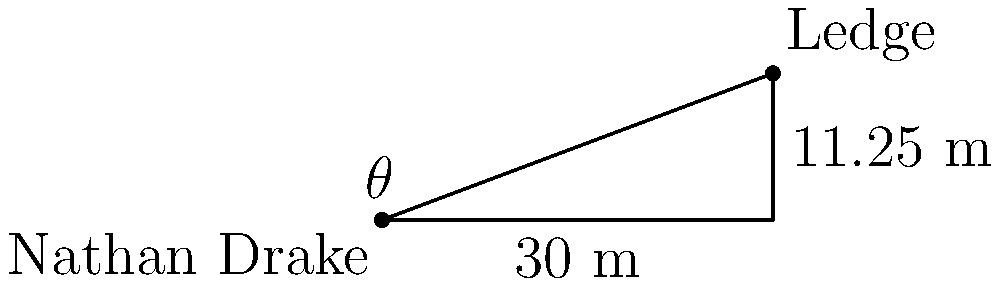Nathan Drake needs to use his grappling hook to reach a ledge. The ledge is 30 meters away horizontally and 11.25 meters above his current position. What angle of elevation (in degrees) should Nathan aim his grappling hook to reach the ledge? To solve this problem, we'll use trigonometry. Let's approach this step-by-step:

1) We can treat this scenario as a right triangle, where:
   - The horizontal distance is the base of the triangle (30 m)
   - The vertical height is the opposite side (11.25 m)
   - The angle we're looking for is the angle of elevation (let's call it $\theta$)

2) In a right triangle, we can use the tangent function to find the angle:

   $\tan(\theta) = \frac{\text{opposite}}{\text{adjacent}} = \frac{\text{height}}{\text{horizontal distance}}$

3) Plugging in our values:

   $\tan(\theta) = \frac{11.25}{30}$

4) To find $\theta$, we need to use the inverse tangent (arctan or $\tan^{-1}$):

   $\theta = \tan^{-1}(\frac{11.25}{30})$

5) Using a calculator or computer:

   $\theta \approx 20.556°$

6) Rounding to the nearest degree:

   $\theta \approx 21°$

Therefore, Nathan Drake should aim his grappling hook at an angle of approximately 21 degrees above the horizontal to reach the ledge.
Answer: 21° 